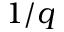Convert formula to latex. <formula><loc_0><loc_0><loc_500><loc_500>1 / q</formula> 